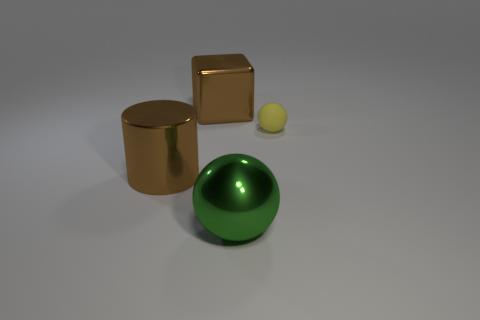Is there any other thing that has the same material as the tiny ball?
Offer a terse response. No. Are the block and the tiny yellow thing made of the same material?
Offer a very short reply. No. How many gray objects are large shiny cylinders or tiny rubber spheres?
Keep it short and to the point. 0. How many large brown objects have the same shape as the small thing?
Your answer should be very brief. 0. What is the yellow thing made of?
Make the answer very short. Rubber. Is the number of big brown shiny objects behind the tiny yellow rubber ball the same as the number of tiny yellow metallic blocks?
Your answer should be compact. No. The brown shiny object that is the same size as the cube is what shape?
Provide a succinct answer. Cylinder. There is a object behind the yellow object; are there any brown shiny cylinders that are behind it?
Provide a short and direct response. No. How many small objects are either cubes or balls?
Offer a very short reply. 1. Are there any cylinders of the same size as the yellow sphere?
Give a very brief answer. No. 